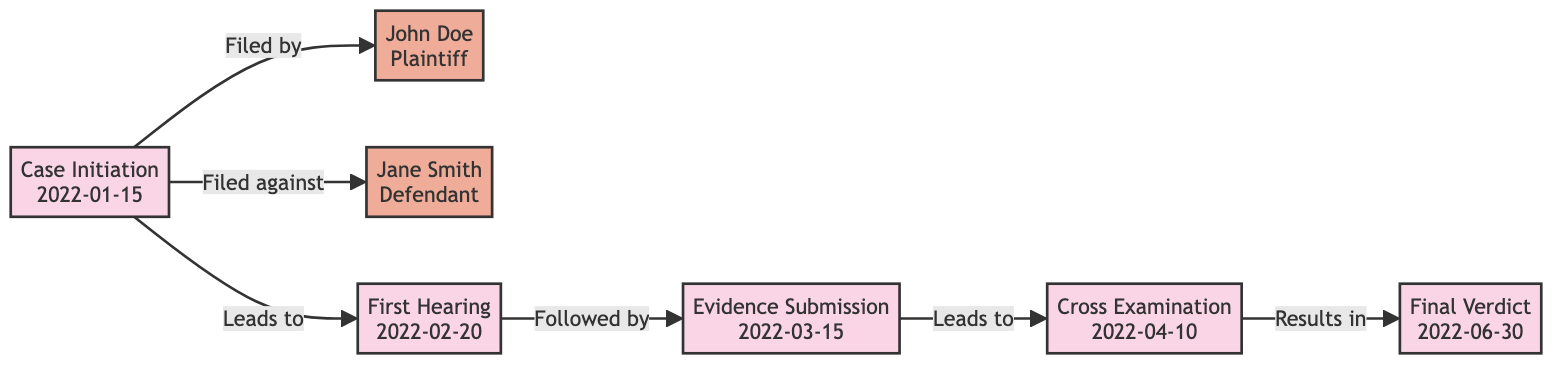What is the date of the Case Initiation? The diagram specifies that the Case Initiation occurs on January 15, 2022, which is clearly labeled in the node for Case Initiation.
Answer: January 15, 2022 Who is the Plaintiff in this case? Referencing the node labeled John Doe, which clearly identifies him as the Plaintiff, we can conclude his role in the case.
Answer: John Doe How many nodes are present in the diagram? Counting the nodes in the diagram, we see there are a total of seven nodes, including the events and parties involved in the case timeline.
Answer: 7 What event occurs after the First Hearing? The arrow leading away from the First Hearing points to the Evidence Submission, indicating that this event directly follows the First Hearing.
Answer: Evidence Submission What is the relationship between the Case Initiation and Jane Smith? The diagram indicates that Jane Smith is filed against by the Case Initiation, as shown by the specific arrow labeled "Filed against."
Answer: Filed against What is the final event in the timeline? Looking at the end of the flow in the diagram, the Final Verdict is the last listed event that occurs, concluding the timeline of the case.
Answer: Final Verdict Which event is directly related to Evidence Submission? The diagram shows that the event Cross Examination directly follows the Evidence Submission, indicating a sequential relationship between these two events.
Answer: Cross Examination What leads to the Final Verdict? By following the edges in the diagram, we can see that the Cross Examination leads to the Final Verdict, making this the preceding event.
Answer: Cross Examination 